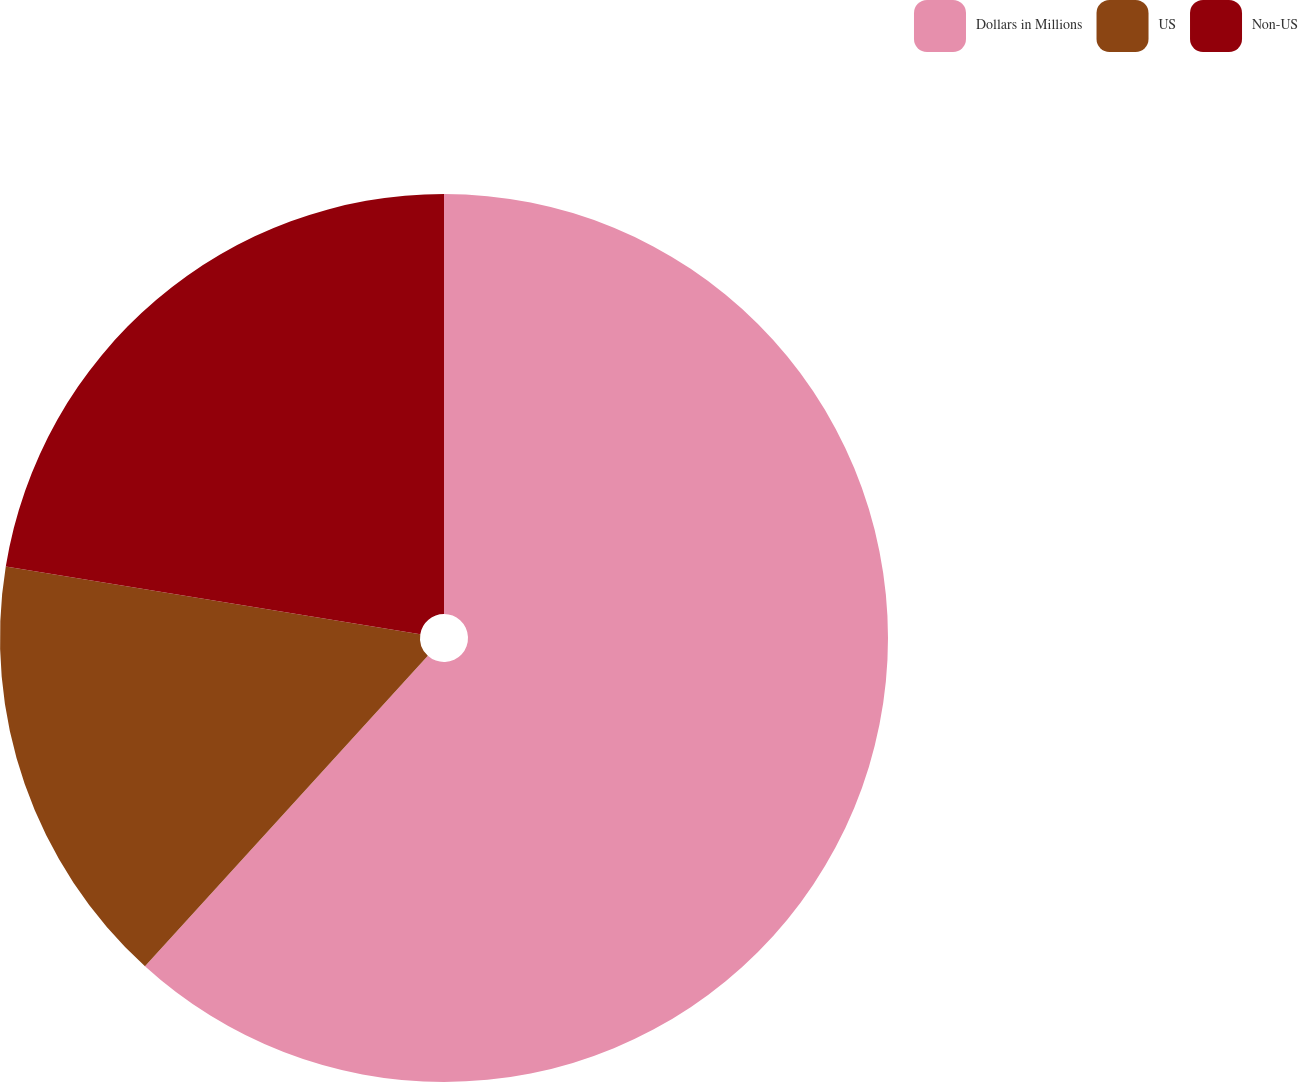Convert chart. <chart><loc_0><loc_0><loc_500><loc_500><pie_chart><fcel>Dollars in Millions<fcel>US<fcel>Non-US<nl><fcel>61.76%<fcel>15.81%<fcel>22.43%<nl></chart> 